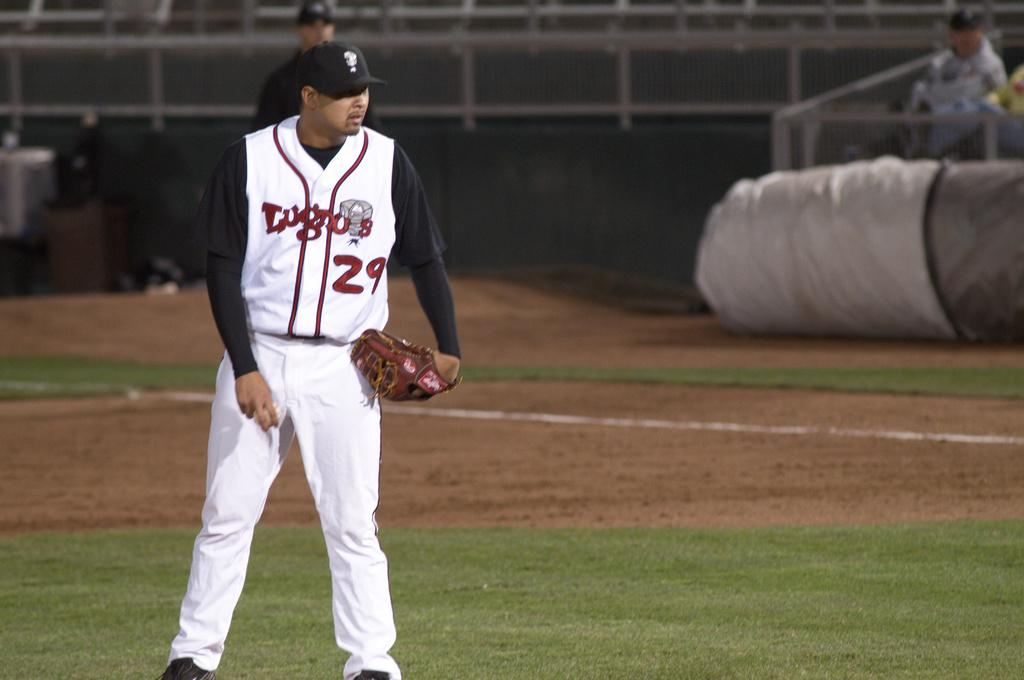<image>
Present a compact description of the photo's key features. Poised at the mound, number 29 waits to deliver a pitch. 